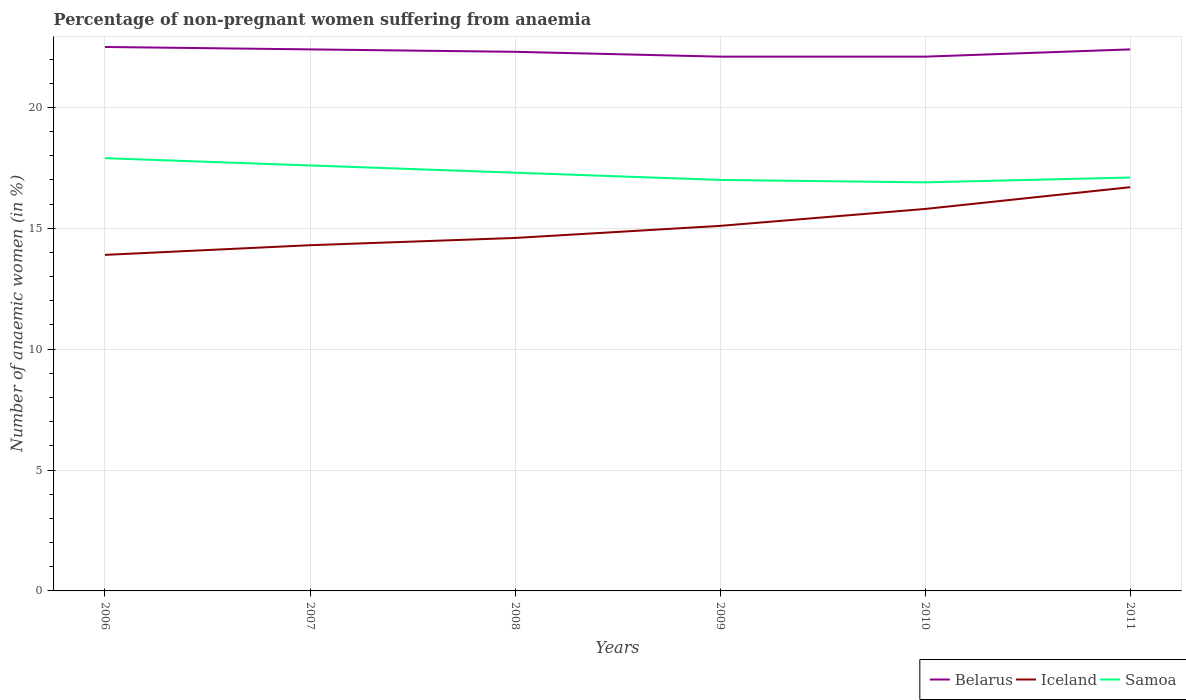Does the line corresponding to Belarus intersect with the line corresponding to Iceland?
Make the answer very short. No. Across all years, what is the maximum percentage of non-pregnant women suffering from anaemia in Iceland?
Provide a short and direct response. 13.9. What is the total percentage of non-pregnant women suffering from anaemia in Belarus in the graph?
Your answer should be compact. 0.1. What is the difference between the highest and the second highest percentage of non-pregnant women suffering from anaemia in Belarus?
Keep it short and to the point. 0.4. How many lines are there?
Make the answer very short. 3. Does the graph contain grids?
Give a very brief answer. Yes. Where does the legend appear in the graph?
Give a very brief answer. Bottom right. How are the legend labels stacked?
Your answer should be very brief. Horizontal. What is the title of the graph?
Your answer should be compact. Percentage of non-pregnant women suffering from anaemia. What is the label or title of the X-axis?
Ensure brevity in your answer.  Years. What is the label or title of the Y-axis?
Provide a short and direct response. Number of anaemic women (in %). What is the Number of anaemic women (in %) of Belarus in 2006?
Make the answer very short. 22.5. What is the Number of anaemic women (in %) of Iceland in 2006?
Your answer should be very brief. 13.9. What is the Number of anaemic women (in %) of Samoa in 2006?
Your answer should be compact. 17.9. What is the Number of anaemic women (in %) of Belarus in 2007?
Keep it short and to the point. 22.4. What is the Number of anaemic women (in %) in Belarus in 2008?
Your response must be concise. 22.3. What is the Number of anaemic women (in %) in Samoa in 2008?
Provide a short and direct response. 17.3. What is the Number of anaemic women (in %) of Belarus in 2009?
Provide a short and direct response. 22.1. What is the Number of anaemic women (in %) of Iceland in 2009?
Provide a short and direct response. 15.1. What is the Number of anaemic women (in %) in Samoa in 2009?
Offer a terse response. 17. What is the Number of anaemic women (in %) in Belarus in 2010?
Offer a very short reply. 22.1. What is the Number of anaemic women (in %) in Iceland in 2010?
Make the answer very short. 15.8. What is the Number of anaemic women (in %) of Samoa in 2010?
Offer a very short reply. 16.9. What is the Number of anaemic women (in %) of Belarus in 2011?
Make the answer very short. 22.4. What is the Number of anaemic women (in %) of Samoa in 2011?
Give a very brief answer. 17.1. Across all years, what is the maximum Number of anaemic women (in %) of Belarus?
Provide a succinct answer. 22.5. Across all years, what is the maximum Number of anaemic women (in %) in Iceland?
Offer a very short reply. 16.7. Across all years, what is the minimum Number of anaemic women (in %) of Belarus?
Keep it short and to the point. 22.1. What is the total Number of anaemic women (in %) of Belarus in the graph?
Offer a terse response. 133.8. What is the total Number of anaemic women (in %) of Iceland in the graph?
Provide a short and direct response. 90.4. What is the total Number of anaemic women (in %) of Samoa in the graph?
Keep it short and to the point. 103.8. What is the difference between the Number of anaemic women (in %) of Samoa in 2006 and that in 2007?
Offer a terse response. 0.3. What is the difference between the Number of anaemic women (in %) of Belarus in 2006 and that in 2009?
Offer a very short reply. 0.4. What is the difference between the Number of anaemic women (in %) in Samoa in 2006 and that in 2009?
Provide a succinct answer. 0.9. What is the difference between the Number of anaemic women (in %) in Belarus in 2006 and that in 2010?
Provide a succinct answer. 0.4. What is the difference between the Number of anaemic women (in %) in Iceland in 2006 and that in 2010?
Your answer should be very brief. -1.9. What is the difference between the Number of anaemic women (in %) in Samoa in 2006 and that in 2010?
Offer a terse response. 1. What is the difference between the Number of anaemic women (in %) in Iceland in 2006 and that in 2011?
Your answer should be compact. -2.8. What is the difference between the Number of anaemic women (in %) of Belarus in 2007 and that in 2008?
Make the answer very short. 0.1. What is the difference between the Number of anaemic women (in %) in Iceland in 2007 and that in 2009?
Your response must be concise. -0.8. What is the difference between the Number of anaemic women (in %) in Belarus in 2007 and that in 2010?
Provide a succinct answer. 0.3. What is the difference between the Number of anaemic women (in %) of Iceland in 2007 and that in 2010?
Provide a short and direct response. -1.5. What is the difference between the Number of anaemic women (in %) of Samoa in 2007 and that in 2011?
Give a very brief answer. 0.5. What is the difference between the Number of anaemic women (in %) of Iceland in 2008 and that in 2009?
Offer a very short reply. -0.5. What is the difference between the Number of anaemic women (in %) of Samoa in 2008 and that in 2009?
Give a very brief answer. 0.3. What is the difference between the Number of anaemic women (in %) in Belarus in 2008 and that in 2010?
Your response must be concise. 0.2. What is the difference between the Number of anaemic women (in %) of Iceland in 2008 and that in 2010?
Your answer should be compact. -1.2. What is the difference between the Number of anaemic women (in %) of Samoa in 2008 and that in 2010?
Give a very brief answer. 0.4. What is the difference between the Number of anaemic women (in %) of Belarus in 2008 and that in 2011?
Provide a succinct answer. -0.1. What is the difference between the Number of anaemic women (in %) of Samoa in 2008 and that in 2011?
Provide a succinct answer. 0.2. What is the difference between the Number of anaemic women (in %) of Iceland in 2009 and that in 2010?
Offer a terse response. -0.7. What is the difference between the Number of anaemic women (in %) in Samoa in 2009 and that in 2011?
Provide a succinct answer. -0.1. What is the difference between the Number of anaemic women (in %) of Iceland in 2010 and that in 2011?
Give a very brief answer. -0.9. What is the difference between the Number of anaemic women (in %) in Belarus in 2006 and the Number of anaemic women (in %) in Iceland in 2007?
Provide a succinct answer. 8.2. What is the difference between the Number of anaemic women (in %) of Iceland in 2006 and the Number of anaemic women (in %) of Samoa in 2008?
Your response must be concise. -3.4. What is the difference between the Number of anaemic women (in %) of Belarus in 2006 and the Number of anaemic women (in %) of Samoa in 2009?
Offer a terse response. 5.5. What is the difference between the Number of anaemic women (in %) in Iceland in 2006 and the Number of anaemic women (in %) in Samoa in 2009?
Your answer should be compact. -3.1. What is the difference between the Number of anaemic women (in %) of Belarus in 2006 and the Number of anaemic women (in %) of Iceland in 2010?
Ensure brevity in your answer.  6.7. What is the difference between the Number of anaemic women (in %) in Belarus in 2006 and the Number of anaemic women (in %) in Samoa in 2010?
Offer a terse response. 5.6. What is the difference between the Number of anaemic women (in %) in Belarus in 2006 and the Number of anaemic women (in %) in Iceland in 2011?
Give a very brief answer. 5.8. What is the difference between the Number of anaemic women (in %) of Iceland in 2006 and the Number of anaemic women (in %) of Samoa in 2011?
Your answer should be very brief. -3.2. What is the difference between the Number of anaemic women (in %) of Belarus in 2007 and the Number of anaemic women (in %) of Samoa in 2008?
Your response must be concise. 5.1. What is the difference between the Number of anaemic women (in %) of Iceland in 2007 and the Number of anaemic women (in %) of Samoa in 2008?
Your response must be concise. -3. What is the difference between the Number of anaemic women (in %) of Belarus in 2007 and the Number of anaemic women (in %) of Iceland in 2009?
Offer a terse response. 7.3. What is the difference between the Number of anaemic women (in %) in Belarus in 2007 and the Number of anaemic women (in %) in Samoa in 2009?
Provide a succinct answer. 5.4. What is the difference between the Number of anaemic women (in %) of Belarus in 2007 and the Number of anaemic women (in %) of Samoa in 2010?
Offer a very short reply. 5.5. What is the difference between the Number of anaemic women (in %) in Iceland in 2007 and the Number of anaemic women (in %) in Samoa in 2010?
Your answer should be very brief. -2.6. What is the difference between the Number of anaemic women (in %) in Belarus in 2008 and the Number of anaemic women (in %) in Iceland in 2009?
Provide a succinct answer. 7.2. What is the difference between the Number of anaemic women (in %) of Iceland in 2008 and the Number of anaemic women (in %) of Samoa in 2009?
Offer a very short reply. -2.4. What is the difference between the Number of anaemic women (in %) of Belarus in 2008 and the Number of anaemic women (in %) of Iceland in 2010?
Your response must be concise. 6.5. What is the difference between the Number of anaemic women (in %) of Belarus in 2008 and the Number of anaemic women (in %) of Iceland in 2011?
Your answer should be compact. 5.6. What is the difference between the Number of anaemic women (in %) in Belarus in 2008 and the Number of anaemic women (in %) in Samoa in 2011?
Make the answer very short. 5.2. What is the difference between the Number of anaemic women (in %) of Belarus in 2009 and the Number of anaemic women (in %) of Samoa in 2010?
Keep it short and to the point. 5.2. What is the difference between the Number of anaemic women (in %) in Iceland in 2009 and the Number of anaemic women (in %) in Samoa in 2010?
Your answer should be compact. -1.8. What is the difference between the Number of anaemic women (in %) of Belarus in 2009 and the Number of anaemic women (in %) of Samoa in 2011?
Your response must be concise. 5. What is the average Number of anaemic women (in %) in Belarus per year?
Your response must be concise. 22.3. What is the average Number of anaemic women (in %) of Iceland per year?
Ensure brevity in your answer.  15.07. In the year 2007, what is the difference between the Number of anaemic women (in %) in Iceland and Number of anaemic women (in %) in Samoa?
Keep it short and to the point. -3.3. In the year 2009, what is the difference between the Number of anaemic women (in %) of Belarus and Number of anaemic women (in %) of Iceland?
Offer a very short reply. 7. In the year 2009, what is the difference between the Number of anaemic women (in %) in Iceland and Number of anaemic women (in %) in Samoa?
Offer a very short reply. -1.9. In the year 2010, what is the difference between the Number of anaemic women (in %) in Belarus and Number of anaemic women (in %) in Iceland?
Provide a succinct answer. 6.3. In the year 2010, what is the difference between the Number of anaemic women (in %) of Belarus and Number of anaemic women (in %) of Samoa?
Offer a terse response. 5.2. In the year 2011, what is the difference between the Number of anaemic women (in %) in Belarus and Number of anaemic women (in %) in Samoa?
Your response must be concise. 5.3. In the year 2011, what is the difference between the Number of anaemic women (in %) of Iceland and Number of anaemic women (in %) of Samoa?
Give a very brief answer. -0.4. What is the ratio of the Number of anaemic women (in %) in Iceland in 2006 to that in 2007?
Offer a terse response. 0.97. What is the ratio of the Number of anaemic women (in %) in Belarus in 2006 to that in 2008?
Your answer should be very brief. 1.01. What is the ratio of the Number of anaemic women (in %) in Iceland in 2006 to that in 2008?
Your answer should be compact. 0.95. What is the ratio of the Number of anaemic women (in %) of Samoa in 2006 to that in 2008?
Offer a terse response. 1.03. What is the ratio of the Number of anaemic women (in %) in Belarus in 2006 to that in 2009?
Provide a short and direct response. 1.02. What is the ratio of the Number of anaemic women (in %) of Iceland in 2006 to that in 2009?
Ensure brevity in your answer.  0.92. What is the ratio of the Number of anaemic women (in %) in Samoa in 2006 to that in 2009?
Your response must be concise. 1.05. What is the ratio of the Number of anaemic women (in %) of Belarus in 2006 to that in 2010?
Offer a very short reply. 1.02. What is the ratio of the Number of anaemic women (in %) in Iceland in 2006 to that in 2010?
Make the answer very short. 0.88. What is the ratio of the Number of anaemic women (in %) in Samoa in 2006 to that in 2010?
Provide a succinct answer. 1.06. What is the ratio of the Number of anaemic women (in %) in Iceland in 2006 to that in 2011?
Make the answer very short. 0.83. What is the ratio of the Number of anaemic women (in %) in Samoa in 2006 to that in 2011?
Offer a terse response. 1.05. What is the ratio of the Number of anaemic women (in %) of Belarus in 2007 to that in 2008?
Ensure brevity in your answer.  1. What is the ratio of the Number of anaemic women (in %) in Iceland in 2007 to that in 2008?
Your answer should be compact. 0.98. What is the ratio of the Number of anaemic women (in %) of Samoa in 2007 to that in 2008?
Offer a very short reply. 1.02. What is the ratio of the Number of anaemic women (in %) of Belarus in 2007 to that in 2009?
Keep it short and to the point. 1.01. What is the ratio of the Number of anaemic women (in %) in Iceland in 2007 to that in 2009?
Your answer should be very brief. 0.95. What is the ratio of the Number of anaemic women (in %) in Samoa in 2007 to that in 2009?
Offer a very short reply. 1.04. What is the ratio of the Number of anaemic women (in %) in Belarus in 2007 to that in 2010?
Provide a short and direct response. 1.01. What is the ratio of the Number of anaemic women (in %) of Iceland in 2007 to that in 2010?
Provide a succinct answer. 0.91. What is the ratio of the Number of anaemic women (in %) in Samoa in 2007 to that in 2010?
Your response must be concise. 1.04. What is the ratio of the Number of anaemic women (in %) of Iceland in 2007 to that in 2011?
Provide a short and direct response. 0.86. What is the ratio of the Number of anaemic women (in %) of Samoa in 2007 to that in 2011?
Make the answer very short. 1.03. What is the ratio of the Number of anaemic women (in %) in Iceland in 2008 to that in 2009?
Your answer should be compact. 0.97. What is the ratio of the Number of anaemic women (in %) of Samoa in 2008 to that in 2009?
Ensure brevity in your answer.  1.02. What is the ratio of the Number of anaemic women (in %) in Iceland in 2008 to that in 2010?
Offer a terse response. 0.92. What is the ratio of the Number of anaemic women (in %) of Samoa in 2008 to that in 2010?
Keep it short and to the point. 1.02. What is the ratio of the Number of anaemic women (in %) in Iceland in 2008 to that in 2011?
Give a very brief answer. 0.87. What is the ratio of the Number of anaemic women (in %) in Samoa in 2008 to that in 2011?
Give a very brief answer. 1.01. What is the ratio of the Number of anaemic women (in %) of Belarus in 2009 to that in 2010?
Offer a terse response. 1. What is the ratio of the Number of anaemic women (in %) in Iceland in 2009 to that in 2010?
Ensure brevity in your answer.  0.96. What is the ratio of the Number of anaemic women (in %) in Samoa in 2009 to that in 2010?
Ensure brevity in your answer.  1.01. What is the ratio of the Number of anaemic women (in %) in Belarus in 2009 to that in 2011?
Offer a terse response. 0.99. What is the ratio of the Number of anaemic women (in %) in Iceland in 2009 to that in 2011?
Make the answer very short. 0.9. What is the ratio of the Number of anaemic women (in %) of Belarus in 2010 to that in 2011?
Ensure brevity in your answer.  0.99. What is the ratio of the Number of anaemic women (in %) of Iceland in 2010 to that in 2011?
Give a very brief answer. 0.95. What is the ratio of the Number of anaemic women (in %) of Samoa in 2010 to that in 2011?
Ensure brevity in your answer.  0.99. What is the difference between the highest and the second highest Number of anaemic women (in %) of Belarus?
Provide a short and direct response. 0.1. What is the difference between the highest and the second highest Number of anaemic women (in %) in Iceland?
Keep it short and to the point. 0.9. What is the difference between the highest and the second highest Number of anaemic women (in %) of Samoa?
Ensure brevity in your answer.  0.3. What is the difference between the highest and the lowest Number of anaemic women (in %) of Belarus?
Make the answer very short. 0.4. What is the difference between the highest and the lowest Number of anaemic women (in %) in Iceland?
Your response must be concise. 2.8. What is the difference between the highest and the lowest Number of anaemic women (in %) in Samoa?
Make the answer very short. 1. 